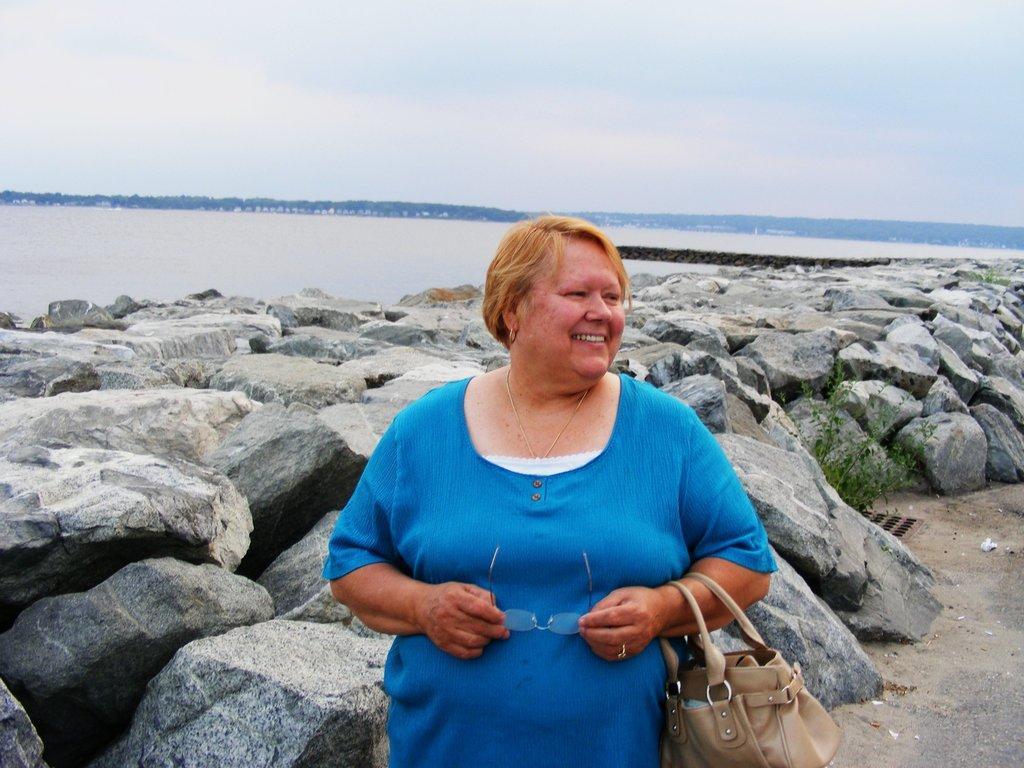Please provide a concise description of this image. In this image I can see a woman standing, she is holding spectacles and a bag. she is wearing a blue dress. There are rocks and water behind her. There are trees at the back. There is sky at the top. 